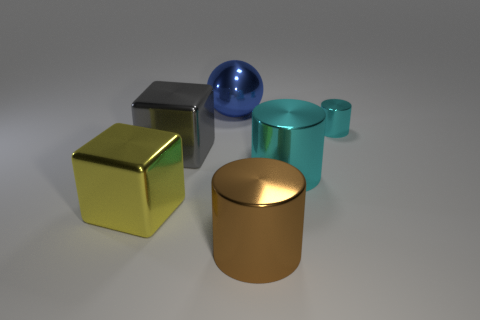How many objects are shiny cylinders that are in front of the large cyan metallic thing or cyan rubber objects?
Offer a terse response. 1. Is there a metallic ball?
Provide a succinct answer. Yes. The metallic object that is both behind the big cyan shiny cylinder and left of the blue metallic object has what shape?
Keep it short and to the point. Cube. How big is the cyan cylinder that is left of the small thing?
Your answer should be compact. Large. There is a cylinder to the left of the big cyan cylinder; does it have the same color as the ball?
Offer a very short reply. No. What number of other objects have the same shape as the large cyan metal object?
Provide a short and direct response. 2. How many things are shiny things to the left of the large blue object or metallic objects behind the brown shiny object?
Your response must be concise. 5. What number of yellow things are either metal spheres or tiny spheres?
Offer a very short reply. 0. The object that is in front of the big cyan cylinder and left of the big brown cylinder is made of what material?
Provide a short and direct response. Metal. Is the material of the big yellow cube the same as the tiny thing?
Provide a succinct answer. Yes. 